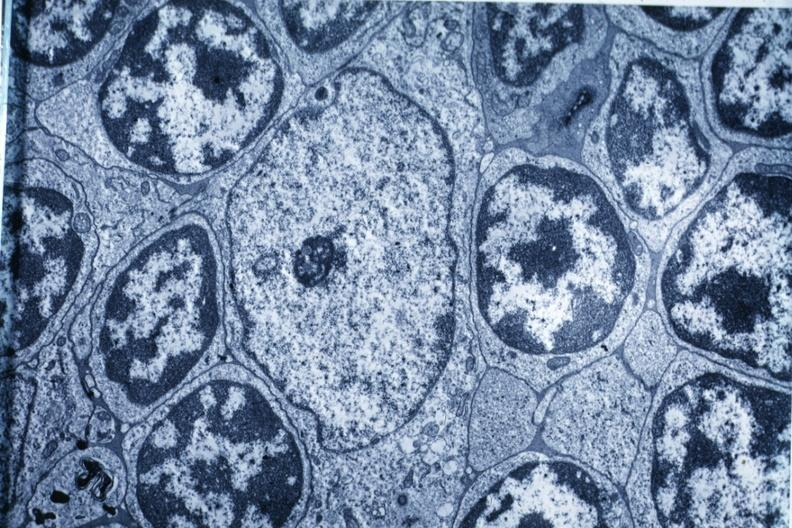s malignant adenoma present?
Answer the question using a single word or phrase. No 